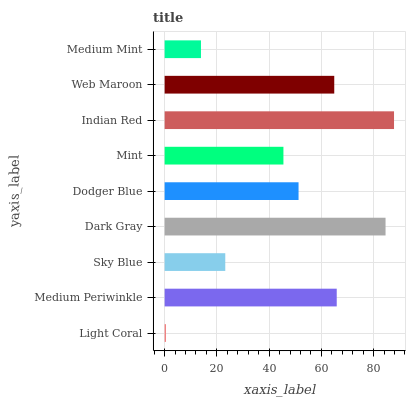Is Light Coral the minimum?
Answer yes or no. Yes. Is Indian Red the maximum?
Answer yes or no. Yes. Is Medium Periwinkle the minimum?
Answer yes or no. No. Is Medium Periwinkle the maximum?
Answer yes or no. No. Is Medium Periwinkle greater than Light Coral?
Answer yes or no. Yes. Is Light Coral less than Medium Periwinkle?
Answer yes or no. Yes. Is Light Coral greater than Medium Periwinkle?
Answer yes or no. No. Is Medium Periwinkle less than Light Coral?
Answer yes or no. No. Is Dodger Blue the high median?
Answer yes or no. Yes. Is Dodger Blue the low median?
Answer yes or no. Yes. Is Light Coral the high median?
Answer yes or no. No. Is Sky Blue the low median?
Answer yes or no. No. 